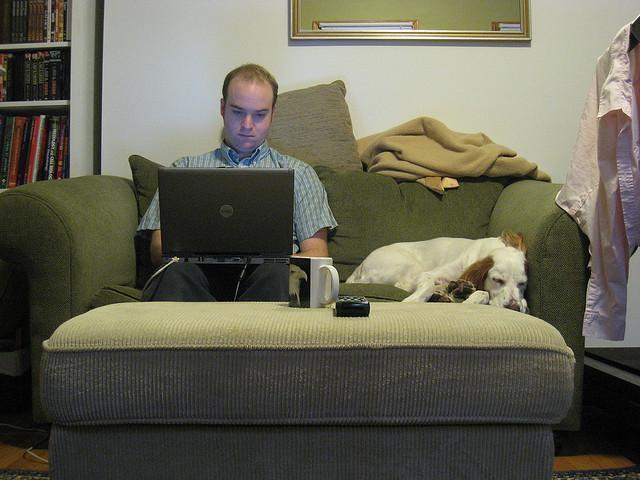Is this affirmation: "The person is on the couch." correct?
Answer yes or no. Yes. 